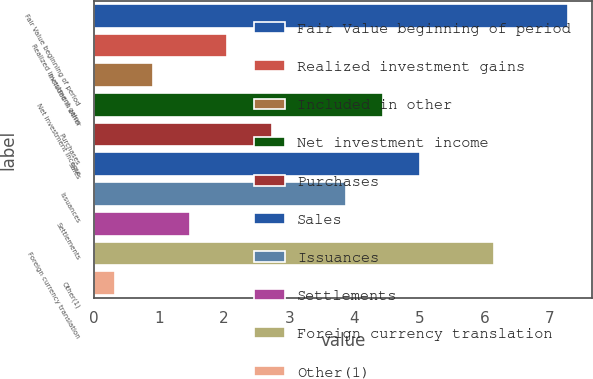Convert chart to OTSL. <chart><loc_0><loc_0><loc_500><loc_500><bar_chart><fcel>Fair Value beginning of period<fcel>Realized investment gains<fcel>Included in other<fcel>Net investment income<fcel>Purchases<fcel>Sales<fcel>Issuances<fcel>Settlements<fcel>Foreign currency translation<fcel>Other(1)<nl><fcel>7.29<fcel>2.04<fcel>0.9<fcel>4.44<fcel>2.73<fcel>5.01<fcel>3.87<fcel>1.47<fcel>6.15<fcel>0.33<nl></chart> 